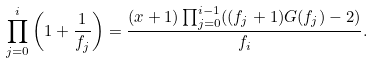Convert formula to latex. <formula><loc_0><loc_0><loc_500><loc_500>\prod _ { j = 0 } ^ { i } \left ( 1 + \frac { 1 } { f _ { j } } \right ) = \frac { ( x + 1 ) \prod _ { j = 0 } ^ { i - 1 } ( ( f _ { j } + 1 ) G ( f _ { j } ) - 2 ) } { f _ { i } } .</formula> 